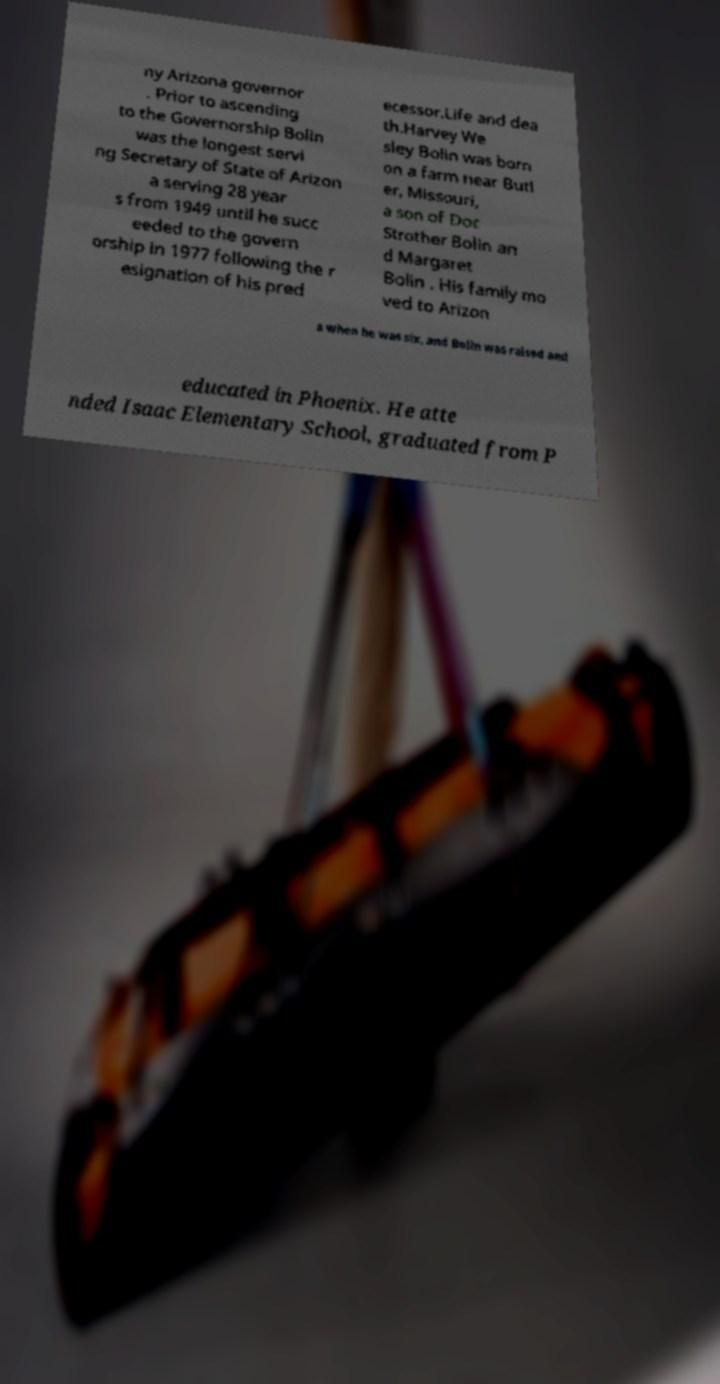Can you accurately transcribe the text from the provided image for me? ny Arizona governor . Prior to ascending to the Governorship Bolin was the longest servi ng Secretary of State of Arizon a serving 28 year s from 1949 until he succ eeded to the govern orship in 1977 following the r esignation of his pred ecessor.Life and dea th.Harvey We sley Bolin was born on a farm near Butl er, Missouri, a son of Doc Strother Bolin an d Margaret Bolin . His family mo ved to Arizon a when he was six, and Bolin was raised and educated in Phoenix. He atte nded Isaac Elementary School, graduated from P 